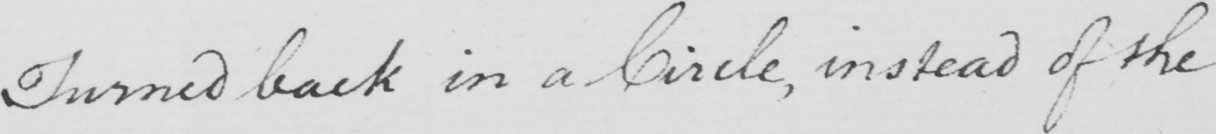Please transcribe the handwritten text in this image. Turned back in a Circle , instead of the 